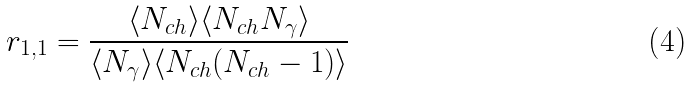<formula> <loc_0><loc_0><loc_500><loc_500>r _ { 1 , 1 } = \frac { \langle N _ { c h } \rangle \langle N _ { c h } N _ { \gamma } \rangle } { \langle N _ { \gamma } \rangle \langle N _ { c h } ( N _ { c h } - 1 ) \rangle }</formula> 